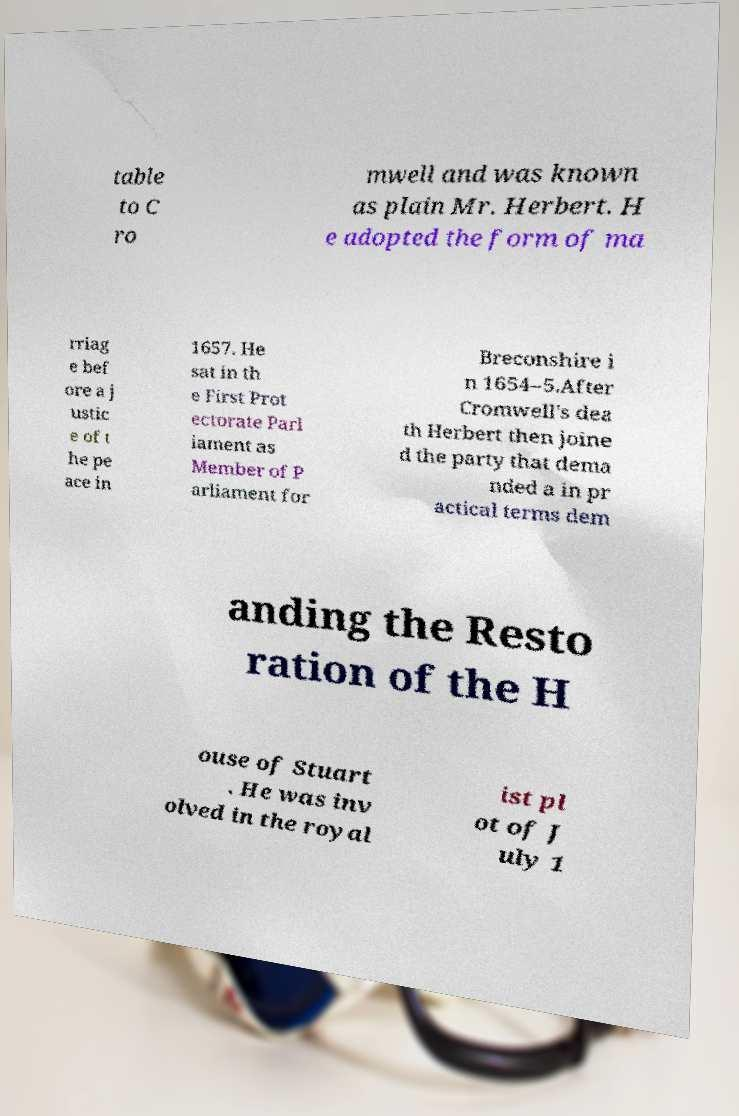For documentation purposes, I need the text within this image transcribed. Could you provide that? table to C ro mwell and was known as plain Mr. Herbert. H e adopted the form of ma rriag e bef ore a j ustic e of t he pe ace in 1657. He sat in th e First Prot ectorate Parl iament as Member of P arliament for Breconshire i n 1654–5.After Cromwell's dea th Herbert then joine d the party that dema nded a in pr actical terms dem anding the Resto ration of the H ouse of Stuart . He was inv olved in the royal ist pl ot of J uly 1 